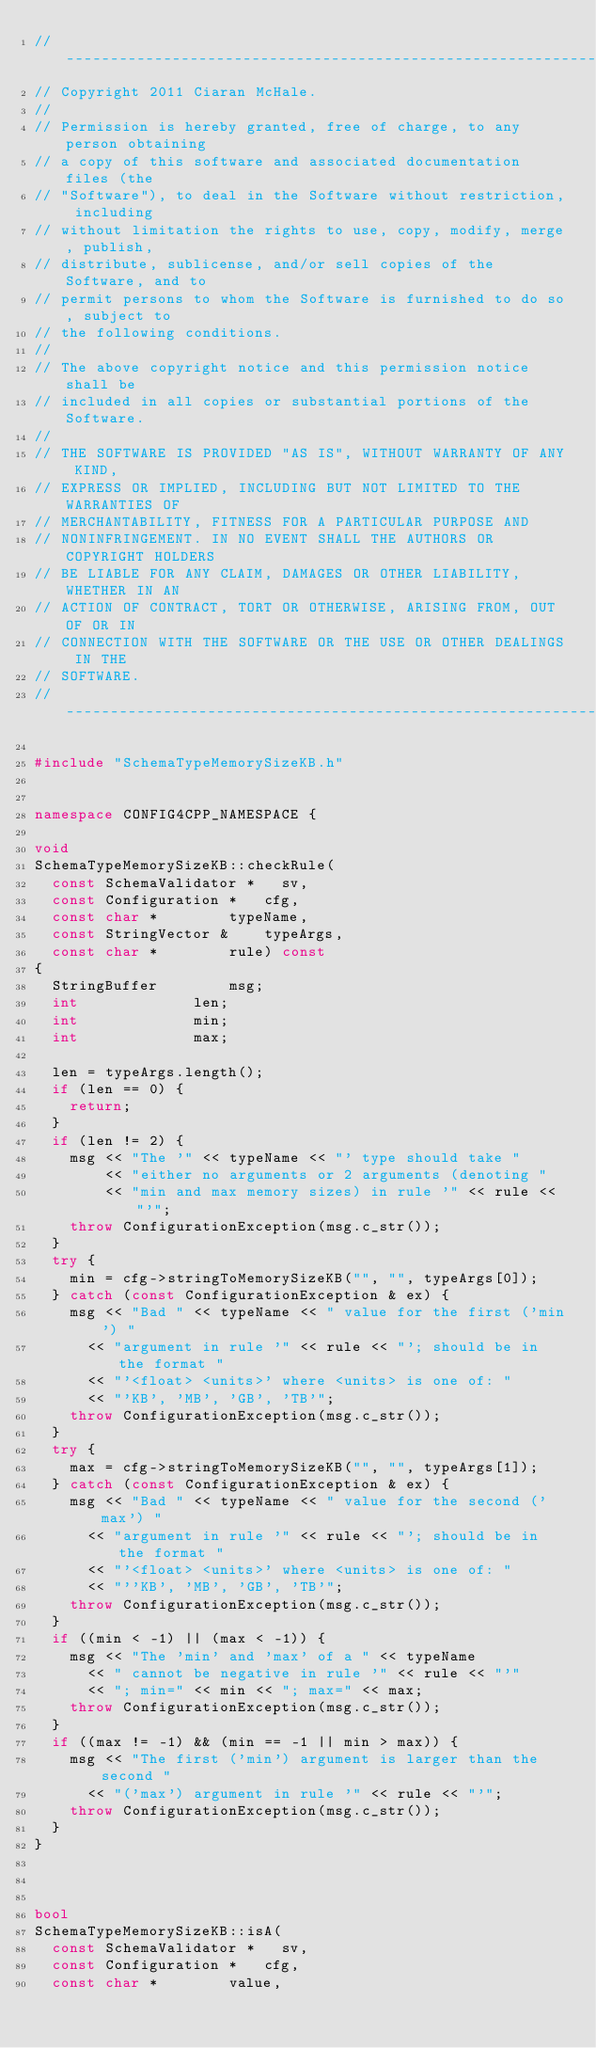<code> <loc_0><loc_0><loc_500><loc_500><_C++_>//-----------------------------------------------------------------------
// Copyright 2011 Ciaran McHale.
//
// Permission is hereby granted, free of charge, to any person obtaining
// a copy of this software and associated documentation files (the
// "Software"), to deal in the Software without restriction, including
// without limitation the rights to use, copy, modify, merge, publish,
// distribute, sublicense, and/or sell copies of the Software, and to
// permit persons to whom the Software is furnished to do so, subject to
// the following conditions.
//
// The above copyright notice and this permission notice shall be
// included in all copies or substantial portions of the Software.  
//
// THE SOFTWARE IS PROVIDED "AS IS", WITHOUT WARRANTY OF ANY KIND,
// EXPRESS OR IMPLIED, INCLUDING BUT NOT LIMITED TO THE WARRANTIES OF
// MERCHANTABILITY, FITNESS FOR A PARTICULAR PURPOSE AND
// NONINFRINGEMENT. IN NO EVENT SHALL THE AUTHORS OR COPYRIGHT HOLDERS
// BE LIABLE FOR ANY CLAIM, DAMAGES OR OTHER LIABILITY, WHETHER IN AN
// ACTION OF CONTRACT, TORT OR OTHERWISE, ARISING FROM, OUT OF OR IN
// CONNECTION WITH THE SOFTWARE OR THE USE OR OTHER DEALINGS IN THE
// SOFTWARE.
//----------------------------------------------------------------------

#include "SchemaTypeMemorySizeKB.h"


namespace CONFIG4CPP_NAMESPACE {

void
SchemaTypeMemorySizeKB::checkRule(
	const SchemaValidator *		sv,
	const Configuration *		cfg,
	const char *				typeName,
	const StringVector &		typeArgs,
	const char *				rule) const
{
	StringBuffer				msg;
	int							len;
	int							min;
	int							max;

	len = typeArgs.length();
	if (len == 0) {
		return;
	}
	if (len != 2) {
		msg << "The '" << typeName << "' type should take "
		    << "either no arguments or 2 arguments (denoting "
		    << "min and max memory sizes) in rule '" << rule << "'";
		throw ConfigurationException(msg.c_str());
	}
	try {
		min = cfg->stringToMemorySizeKB("", "", typeArgs[0]);
	} catch (const ConfigurationException & ex) {
		msg << "Bad " << typeName << " value for the first ('min') "
			<< "argument in rule '" << rule << "'; should be in the format "
			<< "'<float> <units>' where <units> is one of: "
			<< "'KB', 'MB', 'GB', 'TB'";
		throw ConfigurationException(msg.c_str());
	}
	try {
		max = cfg->stringToMemorySizeKB("", "", typeArgs[1]);
	} catch (const ConfigurationException & ex) {
		msg << "Bad " << typeName << " value for the second ('max') "
			<< "argument in rule '" << rule << "'; should be in the format "
			<< "'<float> <units>' where <units> is one of: "
			<< "''KB', 'MB', 'GB', 'TB'";
		throw ConfigurationException(msg.c_str());
	}
	if ((min < -1) || (max < -1)) {
		msg << "The 'min' and 'max' of a " << typeName
			<< " cannot be negative in rule '" << rule << "'"
			<< "; min=" << min << "; max=" << max;
		throw ConfigurationException(msg.c_str());
	}
	if ((max != -1) && (min == -1 || min > max)) {
		msg << "The first ('min') argument is larger than the second "
			<< "('max') argument in rule '" << rule << "'";
		throw ConfigurationException(msg.c_str());
	}
}



bool
SchemaTypeMemorySizeKB::isA(
	const SchemaValidator *		sv,
	const Configuration *		cfg,
	const char *				value,</code> 